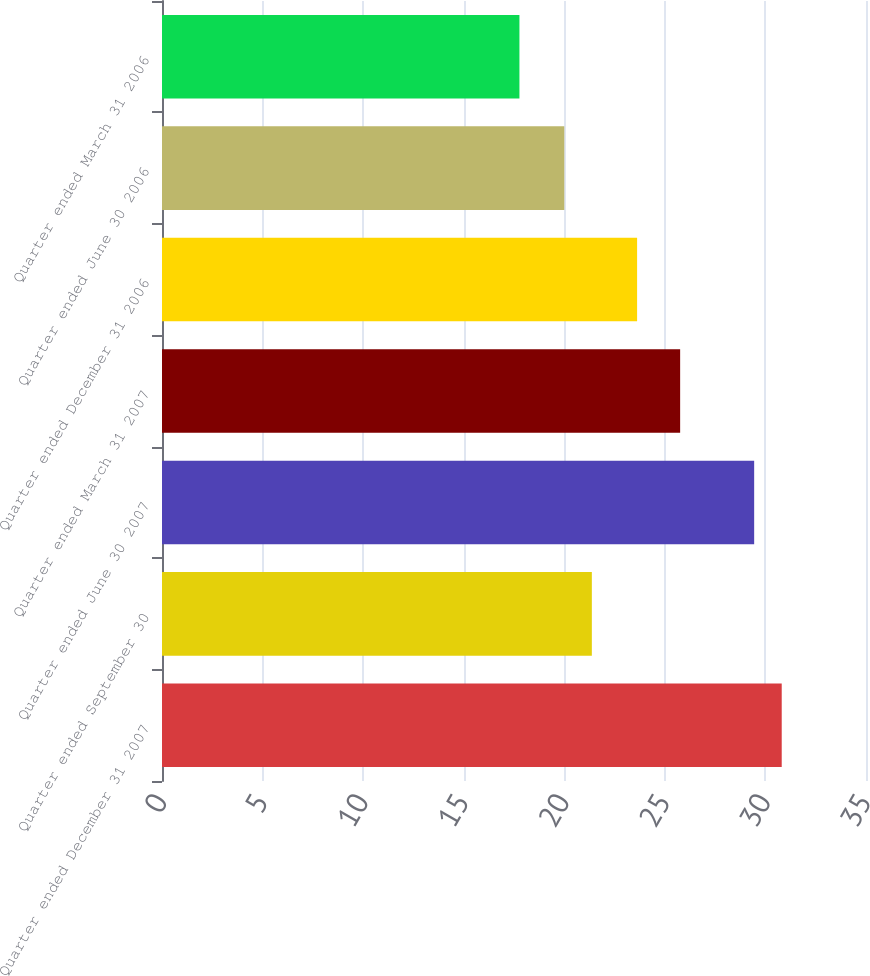<chart> <loc_0><loc_0><loc_500><loc_500><bar_chart><fcel>Quarter ended December 31 2007<fcel>Quarter ended September 30<fcel>Quarter ended June 30 2007<fcel>Quarter ended March 31 2007<fcel>Quarter ended December 31 2006<fcel>Quarter ended June 30 2006<fcel>Quarter ended March 31 2006<nl><fcel>30.81<fcel>21.37<fcel>29.44<fcel>25.76<fcel>23.62<fcel>20<fcel>17.77<nl></chart> 